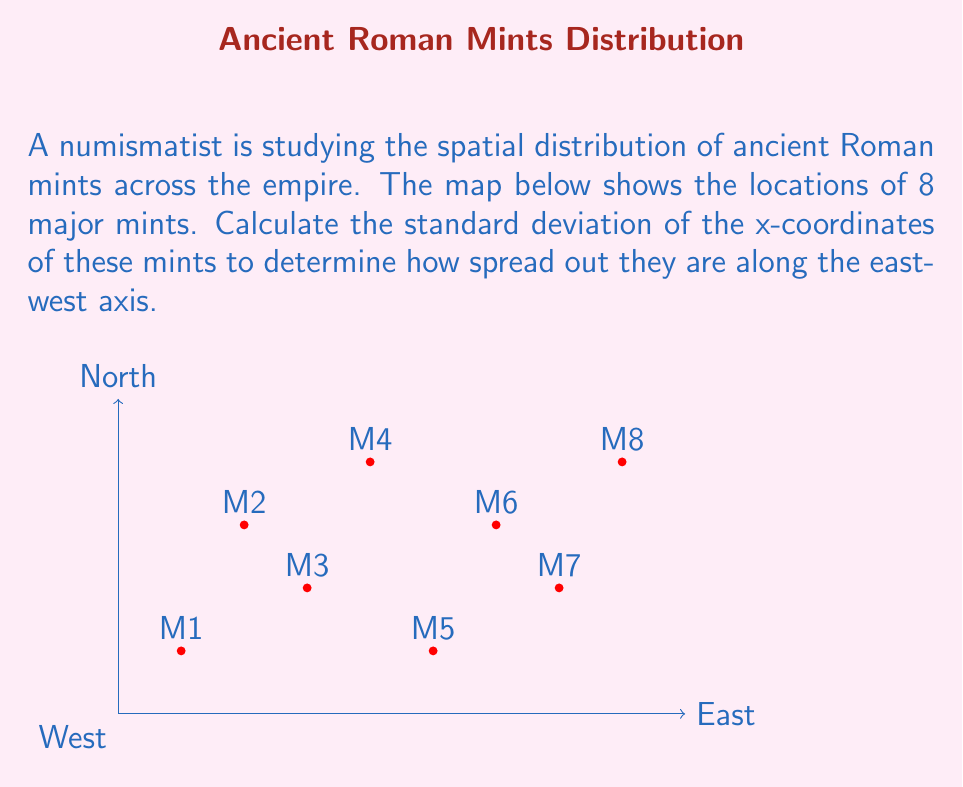Solve this math problem. To calculate the standard deviation of the x-coordinates, we'll follow these steps:

1) First, let's list out the x-coordinates:
   1, 2, 3, 4, 5, 6, 7, 8

2) Calculate the mean (μ) of these x-coordinates:
   $$ \mu = \frac{1 + 2 + 3 + 4 + 5 + 6 + 7 + 8}{8} = \frac{36}{8} = 4.5 $$

3) Calculate the squared differences from the mean:
   $(1 - 4.5)^2 = (-3.5)^2 = 12.25$
   $(2 - 4.5)^2 = (-2.5)^2 = 6.25$
   $(3 - 4.5)^2 = (-1.5)^2 = 2.25$
   $(4 - 4.5)^2 = (-0.5)^2 = 0.25$
   $(5 - 4.5)^2 = (0.5)^2 = 0.25$
   $(6 - 4.5)^2 = (1.5)^2 = 2.25$
   $(7 - 4.5)^2 = (2.5)^2 = 6.25$
   $(8 - 4.5)^2 = (3.5)^2 = 12.25$

4) Calculate the average of these squared differences:
   $$ \frac{12.25 + 6.25 + 2.25 + 0.25 + 0.25 + 2.25 + 6.25 + 12.25}{8} = \frac{42}{8} = 5.25 $$

5) Take the square root of this average to get the standard deviation:
   $$ \sigma = \sqrt{5.25} \approx 2.29 $$

Therefore, the standard deviation of the x-coordinates is approximately 2.29 units.
Answer: $2.29$ 